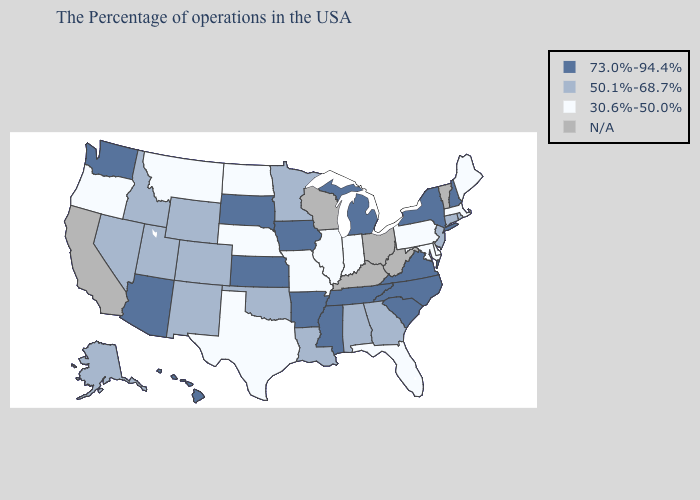What is the value of Arizona?
Concise answer only. 73.0%-94.4%. Name the states that have a value in the range 73.0%-94.4%?
Concise answer only. New Hampshire, New York, Virginia, North Carolina, South Carolina, Michigan, Tennessee, Mississippi, Arkansas, Iowa, Kansas, South Dakota, Arizona, Washington, Hawaii. Among the states that border New Mexico , does Arizona have the highest value?
Be succinct. Yes. Does Indiana have the highest value in the MidWest?
Give a very brief answer. No. Name the states that have a value in the range N/A?
Concise answer only. Vermont, West Virginia, Ohio, Kentucky, Wisconsin, California. Name the states that have a value in the range N/A?
Quick response, please. Vermont, West Virginia, Ohio, Kentucky, Wisconsin, California. What is the value of Louisiana?
Keep it brief. 50.1%-68.7%. What is the value of Michigan?
Concise answer only. 73.0%-94.4%. What is the highest value in the USA?
Write a very short answer. 73.0%-94.4%. Name the states that have a value in the range N/A?
Concise answer only. Vermont, West Virginia, Ohio, Kentucky, Wisconsin, California. Among the states that border Georgia , which have the highest value?
Answer briefly. North Carolina, South Carolina, Tennessee. What is the highest value in the USA?
Be succinct. 73.0%-94.4%. Among the states that border Rhode Island , which have the lowest value?
Write a very short answer. Massachusetts. Name the states that have a value in the range 30.6%-50.0%?
Give a very brief answer. Maine, Massachusetts, Delaware, Maryland, Pennsylvania, Florida, Indiana, Illinois, Missouri, Nebraska, Texas, North Dakota, Montana, Oregon. Among the states that border Ohio , does Indiana have the lowest value?
Answer briefly. Yes. 